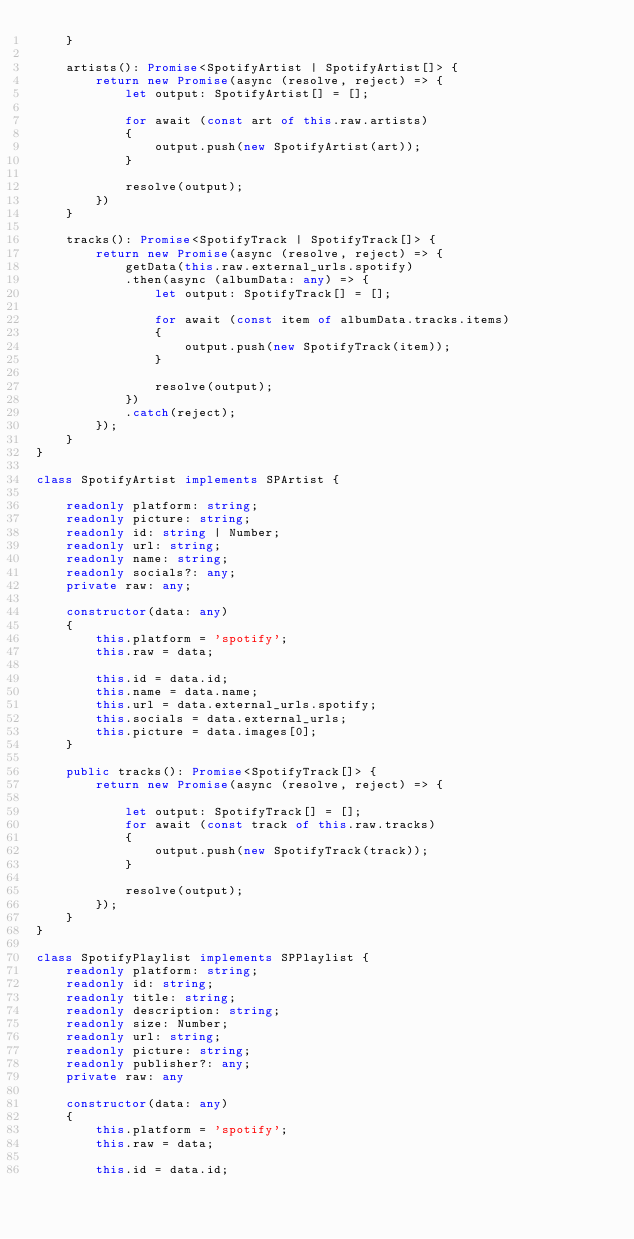Convert code to text. <code><loc_0><loc_0><loc_500><loc_500><_TypeScript_>    }

    artists(): Promise<SpotifyArtist | SpotifyArtist[]> {
        return new Promise(async (resolve, reject) => {
            let output: SpotifyArtist[] = [];
                
            for await (const art of this.raw.artists)
            {
                output.push(new SpotifyArtist(art));
            }

            resolve(output);
        })
    }

    tracks(): Promise<SpotifyTrack | SpotifyTrack[]> {
        return new Promise(async (resolve, reject) => {
            getData(this.raw.external_urls.spotify)
            .then(async (albumData: any) => {
                let output: SpotifyTrack[] = [];

                for await (const item of albumData.tracks.items)
                {
                    output.push(new SpotifyTrack(item));
                }

                resolve(output);
            })
            .catch(reject);
        });
    }
}

class SpotifyArtist implements SPArtist {

    readonly platform: string;
    readonly picture: string;
    readonly id: string | Number;
    readonly url: string;
    readonly name: string;
    readonly socials?: any;
    private raw: any;

    constructor(data: any)
    {
        this.platform = 'spotify';
        this.raw = data;

        this.id = data.id;
        this.name = data.name;
        this.url = data.external_urls.spotify;
        this.socials = data.external_urls;
        this.picture = data.images[0];
    }

    public tracks(): Promise<SpotifyTrack[]> {
        return new Promise(async (resolve, reject) => {
            
            let output: SpotifyTrack[] = [];
            for await (const track of this.raw.tracks)
            {
                output.push(new SpotifyTrack(track));
            }

            resolve(output);
        });
    }
}

class SpotifyPlaylist implements SPPlaylist {
    readonly platform: string;
    readonly id: string;
    readonly title: string;
    readonly description: string;
    readonly size: Number;
    readonly url: string;
    readonly picture: string;
    readonly publisher?: any;
    private raw: any

    constructor(data: any)
    {
        this.platform = 'spotify';
        this.raw = data;

        this.id = data.id;</code> 